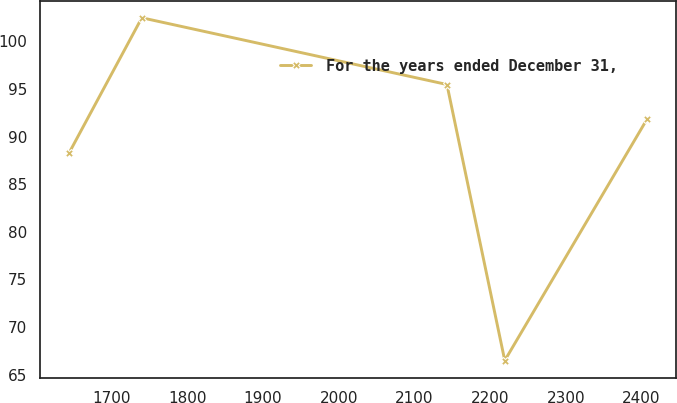<chart> <loc_0><loc_0><loc_500><loc_500><line_chart><ecel><fcel>For the years ended December 31,<nl><fcel>1643.71<fcel>88.27<nl><fcel>1739.87<fcel>102.48<nl><fcel>2142.91<fcel>95.47<nl><fcel>2219.29<fcel>66.48<nl><fcel>2407.48<fcel>91.87<nl></chart> 